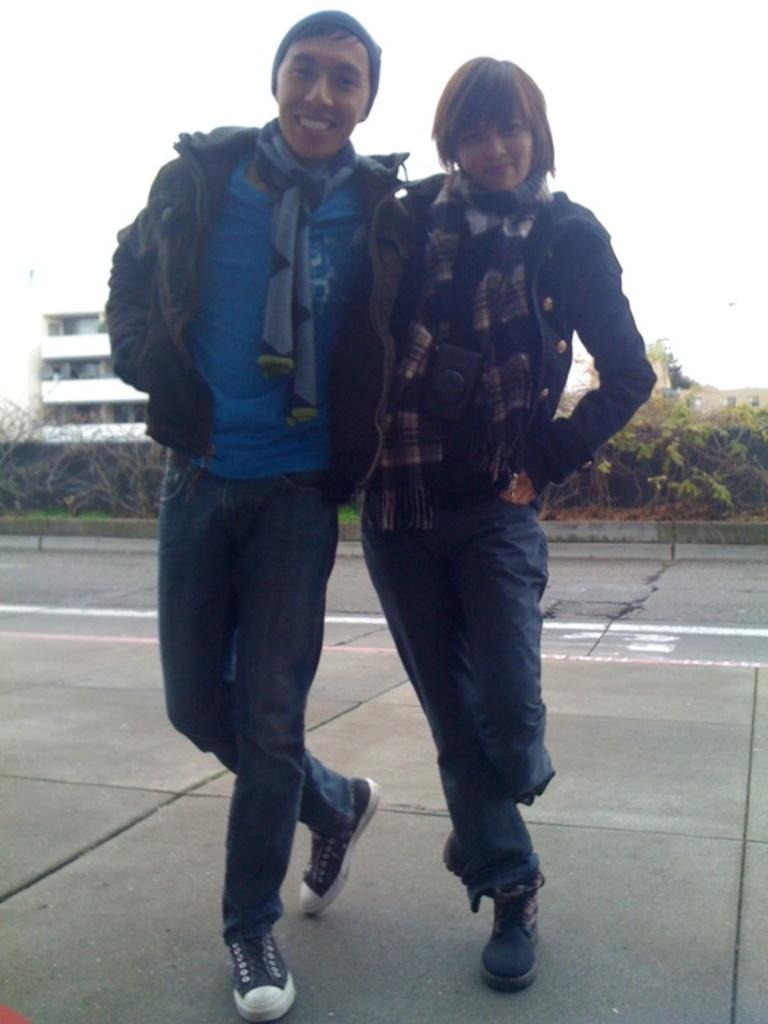How many people are in the image? There are two persons in the image. What expressions do the people have? Both persons are smiling. What can be seen in the background of the image? There are trees and buildings visible in the background of the image. What type of lunch is being served to the hen in the image? There is no hen or lunch present in the image; it features two smiling people and a background with trees and buildings. 